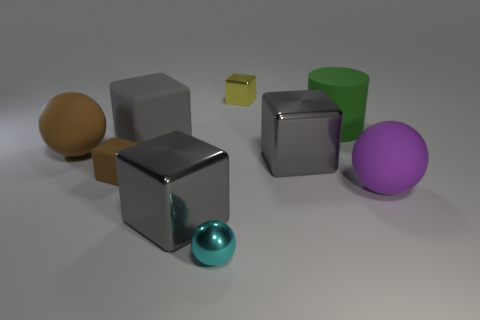How many small things are brown rubber spheres or gray things?
Your answer should be very brief. 0. What number of balls are behind the tiny ball and in front of the big purple matte object?
Give a very brief answer. 0. Are there more big gray metal cubes than cyan balls?
Provide a succinct answer. Yes. What number of other objects are there of the same shape as the large purple object?
Offer a very short reply. 2. Is the metal sphere the same color as the big cylinder?
Give a very brief answer. No. There is a small object that is both behind the purple ball and in front of the tiny metal block; what material is it?
Offer a terse response. Rubber. What is the size of the cyan shiny thing?
Your answer should be compact. Small. How many large things are behind the big matte ball that is in front of the large gray metallic object that is right of the tiny metal ball?
Make the answer very short. 4. There is a gray metallic thing that is in front of the large gray metal cube right of the metal sphere; what shape is it?
Your response must be concise. Cube. What size is the gray matte thing that is the same shape as the yellow thing?
Provide a succinct answer. Large. 